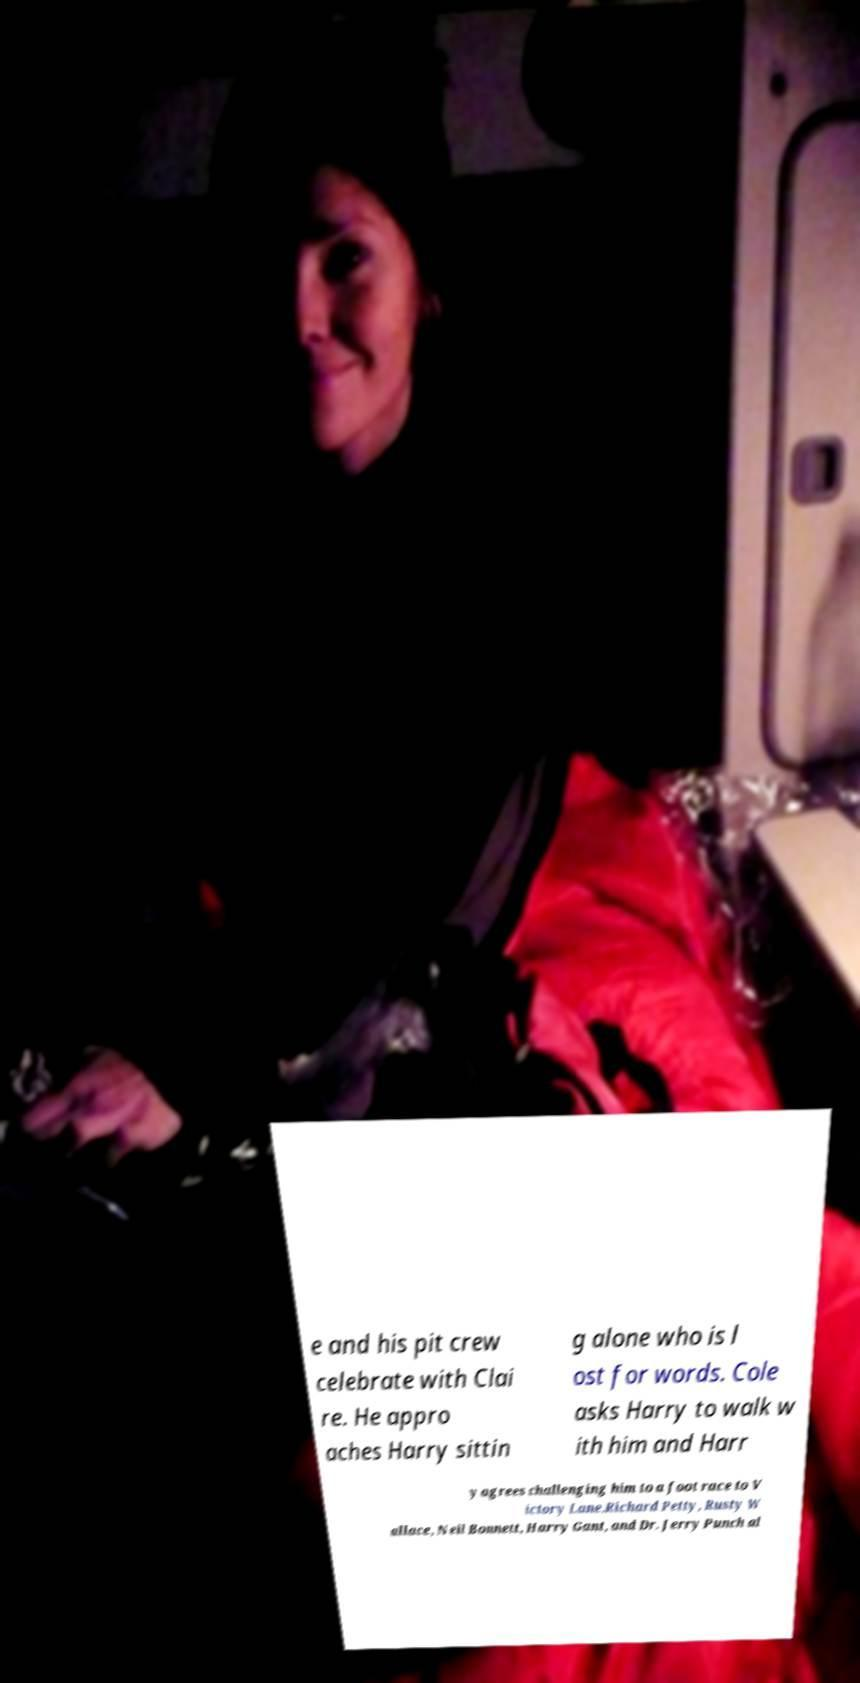Can you accurately transcribe the text from the provided image for me? e and his pit crew celebrate with Clai re. He appro aches Harry sittin g alone who is l ost for words. Cole asks Harry to walk w ith him and Harr y agrees challenging him to a foot race to V ictory Lane.Richard Petty, Rusty W allace, Neil Bonnett, Harry Gant, and Dr. Jerry Punch al 